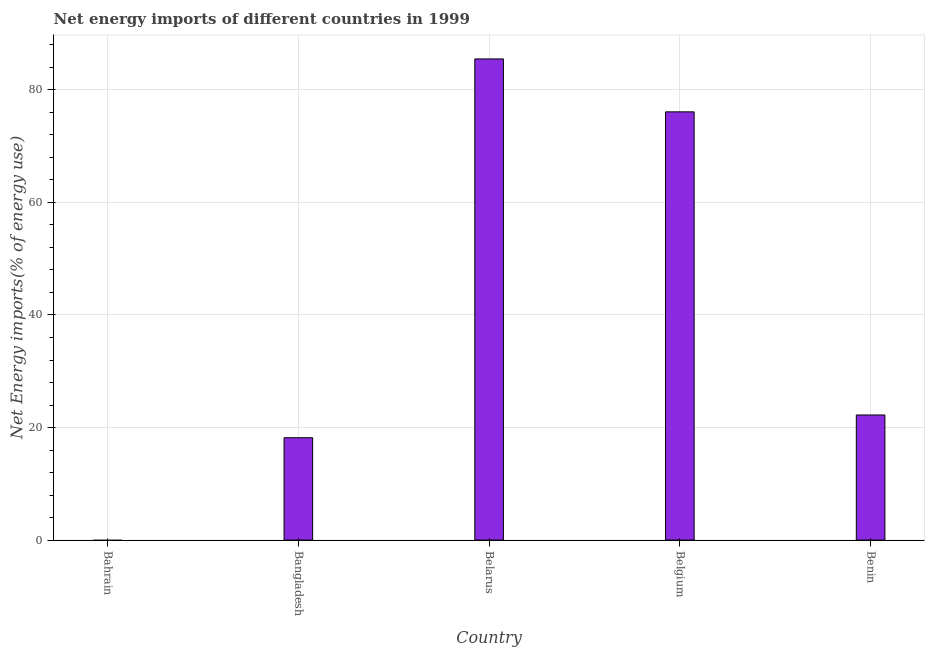What is the title of the graph?
Give a very brief answer. Net energy imports of different countries in 1999. What is the label or title of the Y-axis?
Offer a terse response. Net Energy imports(% of energy use). What is the energy imports in Bahrain?
Ensure brevity in your answer.  0. Across all countries, what is the maximum energy imports?
Keep it short and to the point. 85.5. In which country was the energy imports maximum?
Provide a succinct answer. Belarus. What is the sum of the energy imports?
Your response must be concise. 202.02. What is the difference between the energy imports in Belgium and Benin?
Offer a terse response. 53.87. What is the average energy imports per country?
Offer a terse response. 40.4. What is the median energy imports?
Your answer should be very brief. 22.23. In how many countries, is the energy imports greater than 48 %?
Keep it short and to the point. 2. What is the ratio of the energy imports in Bangladesh to that in Benin?
Give a very brief answer. 0.82. Is the energy imports in Bangladesh less than that in Benin?
Offer a terse response. Yes. What is the difference between the highest and the second highest energy imports?
Your answer should be very brief. 9.4. What is the difference between the highest and the lowest energy imports?
Your answer should be compact. 85.5. How many countries are there in the graph?
Make the answer very short. 5. What is the Net Energy imports(% of energy use) in Bangladesh?
Provide a short and direct response. 18.19. What is the Net Energy imports(% of energy use) of Belarus?
Your answer should be very brief. 85.5. What is the Net Energy imports(% of energy use) in Belgium?
Provide a succinct answer. 76.1. What is the Net Energy imports(% of energy use) in Benin?
Your answer should be very brief. 22.23. What is the difference between the Net Energy imports(% of energy use) in Bangladesh and Belarus?
Make the answer very short. -67.31. What is the difference between the Net Energy imports(% of energy use) in Bangladesh and Belgium?
Offer a terse response. -57.91. What is the difference between the Net Energy imports(% of energy use) in Bangladesh and Benin?
Give a very brief answer. -4.04. What is the difference between the Net Energy imports(% of energy use) in Belarus and Belgium?
Ensure brevity in your answer.  9.4. What is the difference between the Net Energy imports(% of energy use) in Belarus and Benin?
Keep it short and to the point. 63.27. What is the difference between the Net Energy imports(% of energy use) in Belgium and Benin?
Provide a succinct answer. 53.87. What is the ratio of the Net Energy imports(% of energy use) in Bangladesh to that in Belarus?
Keep it short and to the point. 0.21. What is the ratio of the Net Energy imports(% of energy use) in Bangladesh to that in Belgium?
Ensure brevity in your answer.  0.24. What is the ratio of the Net Energy imports(% of energy use) in Bangladesh to that in Benin?
Provide a short and direct response. 0.82. What is the ratio of the Net Energy imports(% of energy use) in Belarus to that in Belgium?
Offer a very short reply. 1.12. What is the ratio of the Net Energy imports(% of energy use) in Belarus to that in Benin?
Offer a very short reply. 3.85. What is the ratio of the Net Energy imports(% of energy use) in Belgium to that in Benin?
Provide a succinct answer. 3.42. 